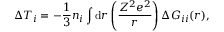Convert formula to latex. <formula><loc_0><loc_0><loc_500><loc_500>\Delta T _ { i } = - \frac { 1 } { 3 } n _ { i } \int d r \left ( \frac { Z ^ { 2 } e ^ { 2 } } { r } \right ) \Delta G _ { i i } ( r ) ,</formula> 